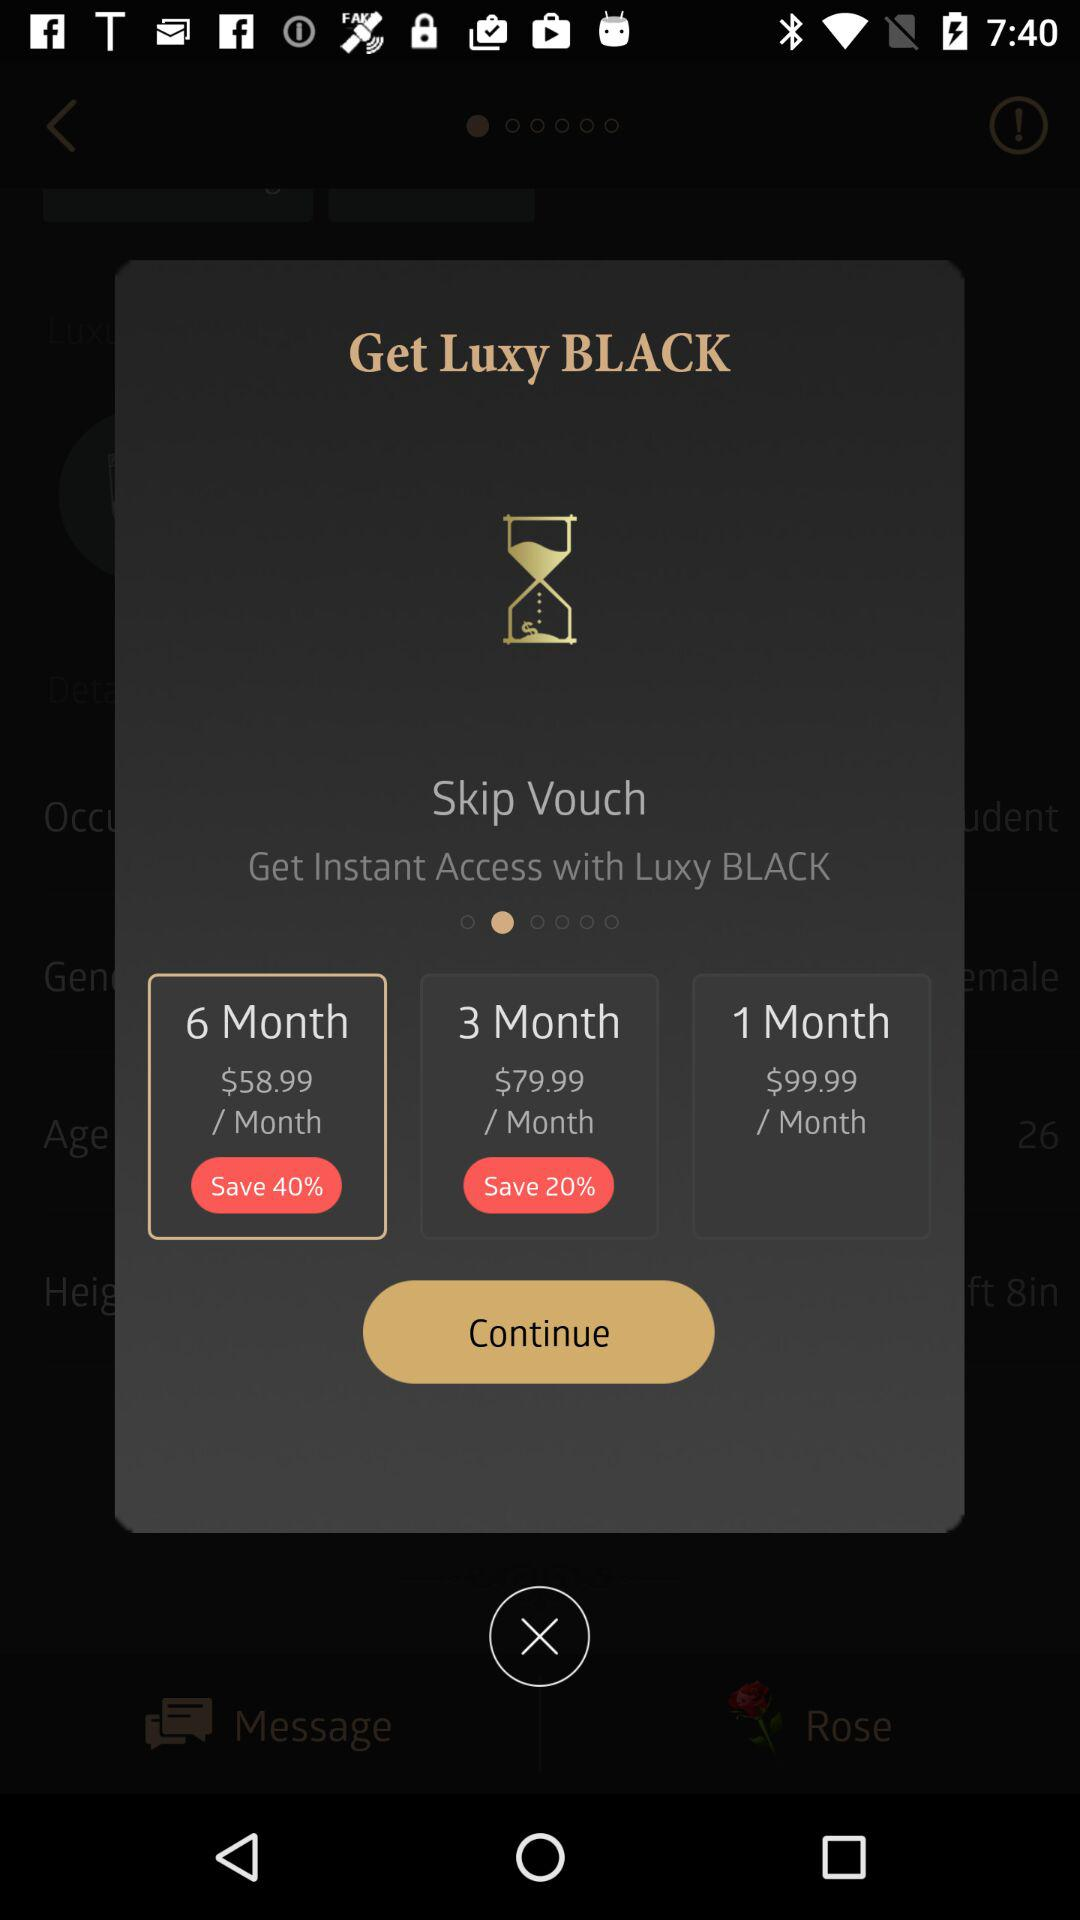How much more does the 1-month plan cost than the 6-month plan?
Answer the question using a single word or phrase. $41.00 